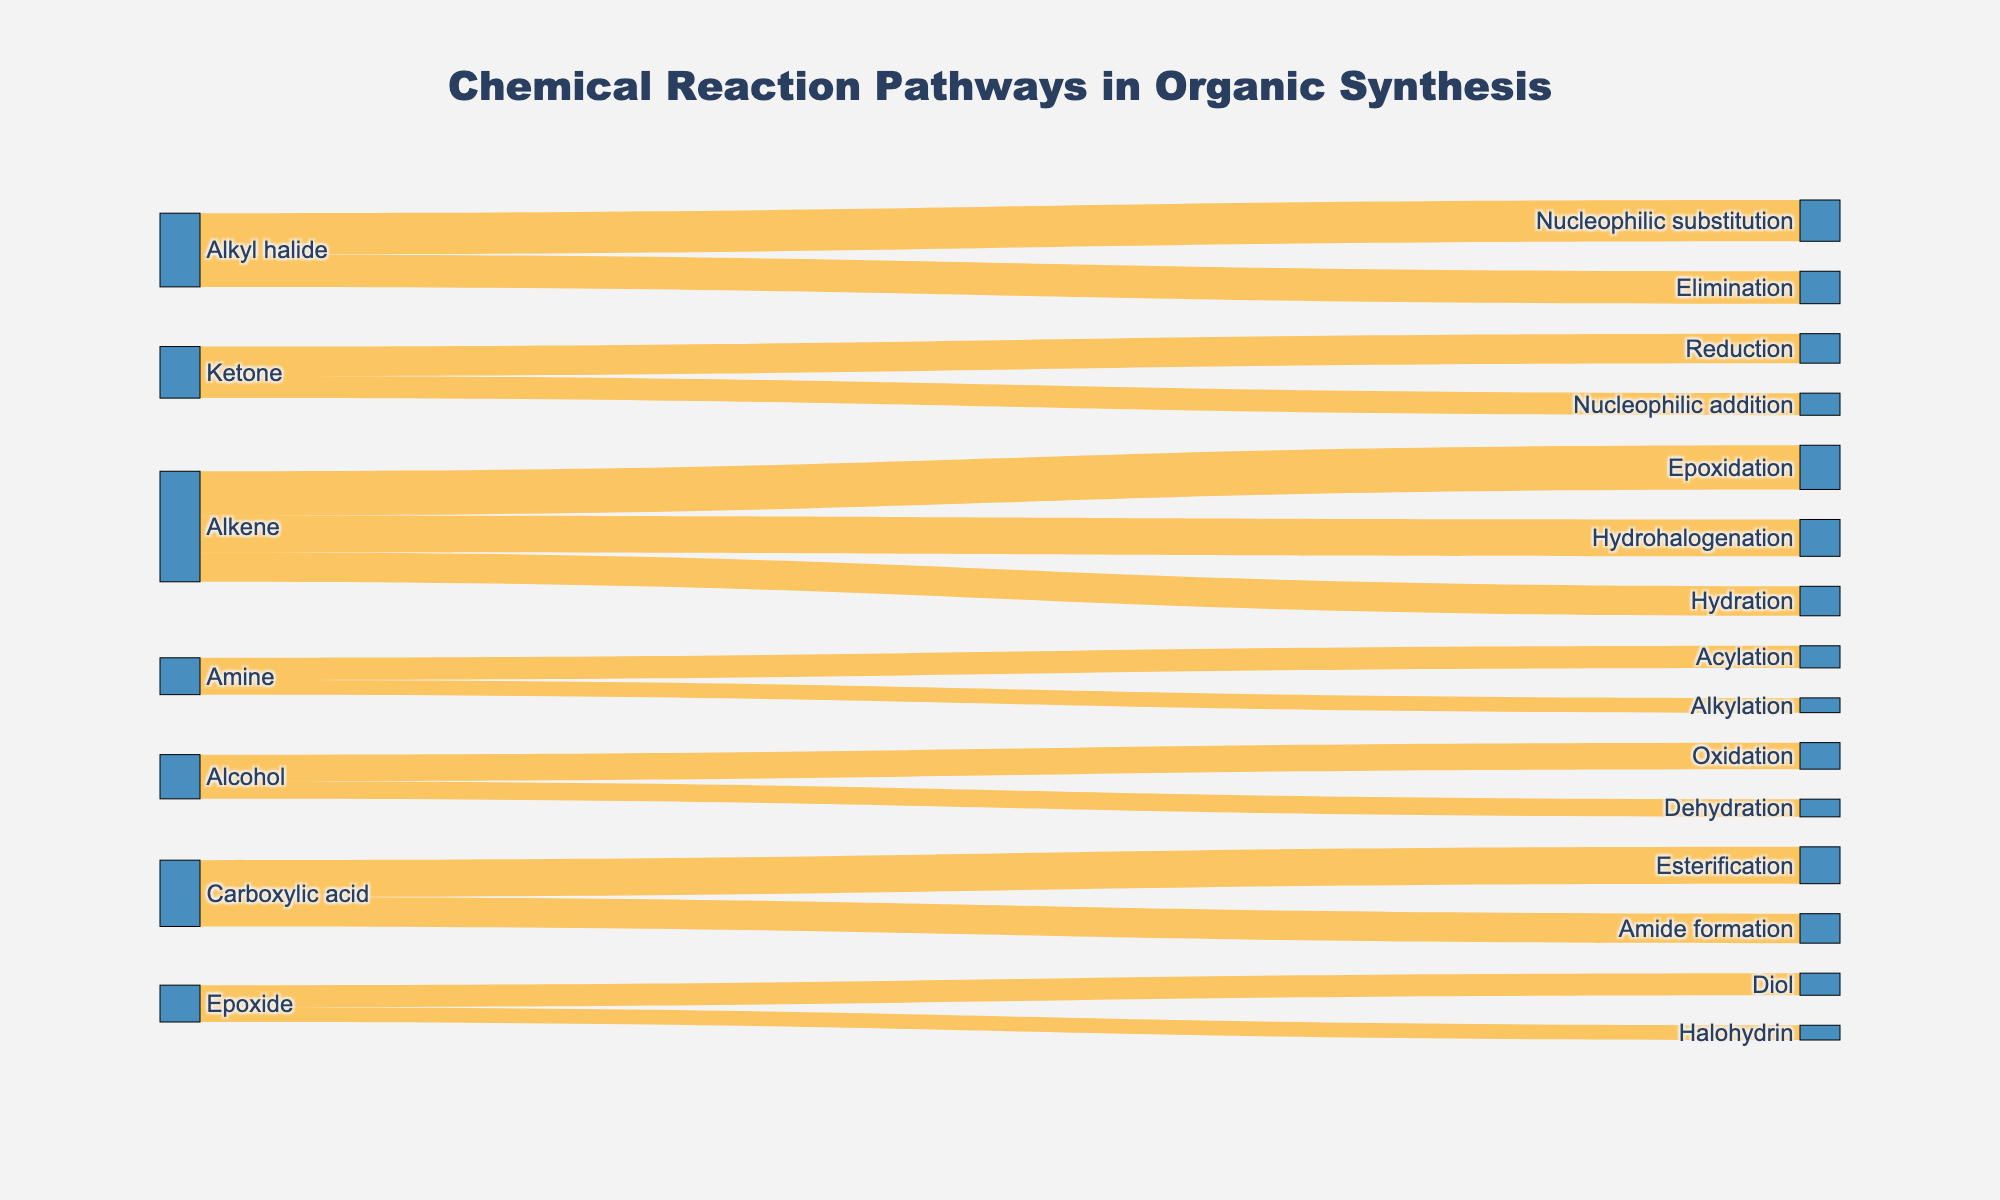What is the title of the Sankey Diagram? The title of a graphical visualization is usually placed at the top of the figure. In this case, it's indicating what the entire diagram represents.
Answer: Chemical Reaction Pathways in Organic Synthesis How many reaction pathways originate from Alkenes? Examine the diagram to see how many lines (pathways) originate from the "Alkene" node.
Answer: 3 Which reaction has the highest value originating from an Alkene? Look at the values of the pathways originating from "Alkene" and compare them. The one with the highest value is the answer.
Answer: Epoxidation What is the total value of all pathways originating from Alkyl halides? Sum the individual values of the pathways that start from "Alkyl halide". Those values are 22 for Elimination and 28 for Nucleophilic substitution. Calculate: 22 + 28.
Answer: 50 Which pathway has a higher value, Alcohol to Oxidation or Alcohol to Dehydration? Compare the value of the pathway from "Alcohol" to "Oxidation" (18) with the value from "Alcohol" to "Dehydration" (12).
Answer: Alcohol to Oxidation Out of Epoxide's pathways, which one has the lowest value? Compare the values of pathways originating from "Epoxide", which are Epoxide to Diol (15) and Epoxide to Halohydrin (10).
Answer: Halohydrin How many unique nodes are there in the Sankey Diagram? Count all the unique points (nodes) in the diagram. These are distinct starting and ending points of the pathways.
Answer: 12 If you add the values of all pathways originating from Alkenes and Alkyl halides, what is the total value? First, sum up the values for Alkenes (30 + 25 + 20 = 75) and Alkyl halides (22 + 28 = 50). Then, add these two results together: 75 + 50.
Answer: 125 Is the pathway value from Amine to Acylation greater than the pathway value from Amine to Alkylation? Compare the value of the pathway from Amine to Acylation (15) with the pathway value from Amine to Alkylation (10).
Answer: Yes Which node has the most outgoing pathways, and how many? Identify which node has the highest number of lines (pathways) originating from it.
Answer: Alkene, 3 